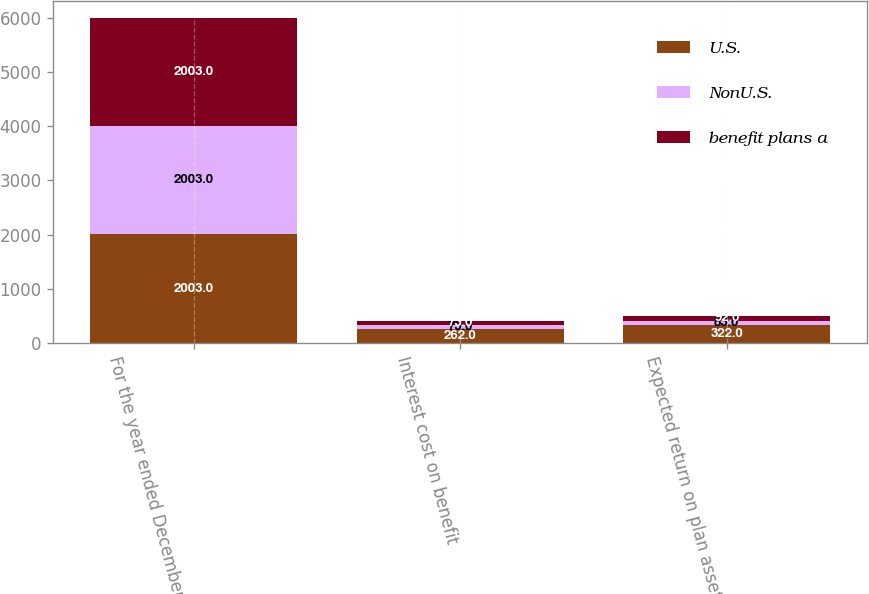Convert chart to OTSL. <chart><loc_0><loc_0><loc_500><loc_500><stacked_bar_chart><ecel><fcel>For the year ended December 31<fcel>Interest cost on benefit<fcel>Expected return on plan assets<nl><fcel>U.S.<fcel>2003<fcel>262<fcel>322<nl><fcel>NonU.S.<fcel>2003<fcel>73<fcel>83<nl><fcel>benefit plans a<fcel>2003<fcel>73<fcel>92<nl></chart> 